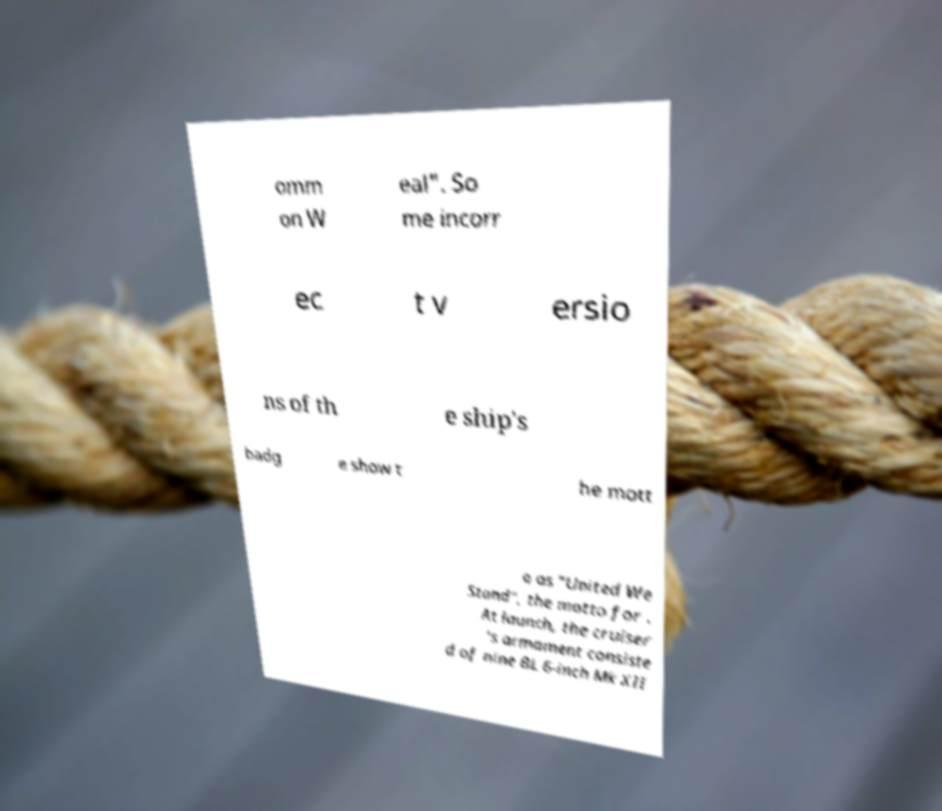Please identify and transcribe the text found in this image. omm on W eal". So me incorr ec t v ersio ns of th e ship's badg e show t he mott o as "United We Stand", the motto for . At launch, the cruiser 's armament consiste d of nine BL 6-inch Mk XII 